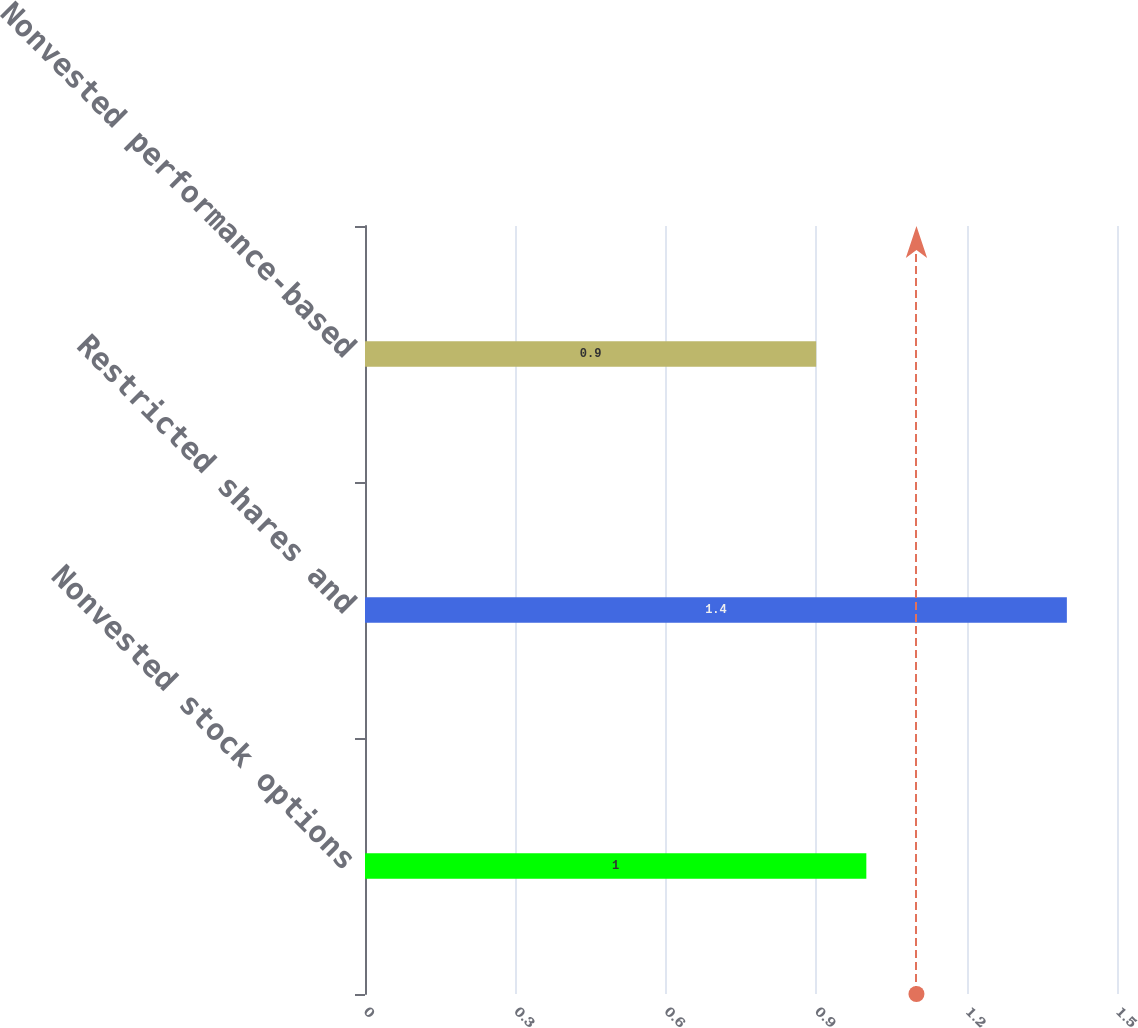<chart> <loc_0><loc_0><loc_500><loc_500><bar_chart><fcel>Nonvested stock options<fcel>Restricted shares and<fcel>Nonvested performance-based<nl><fcel>1<fcel>1.4<fcel>0.9<nl></chart> 